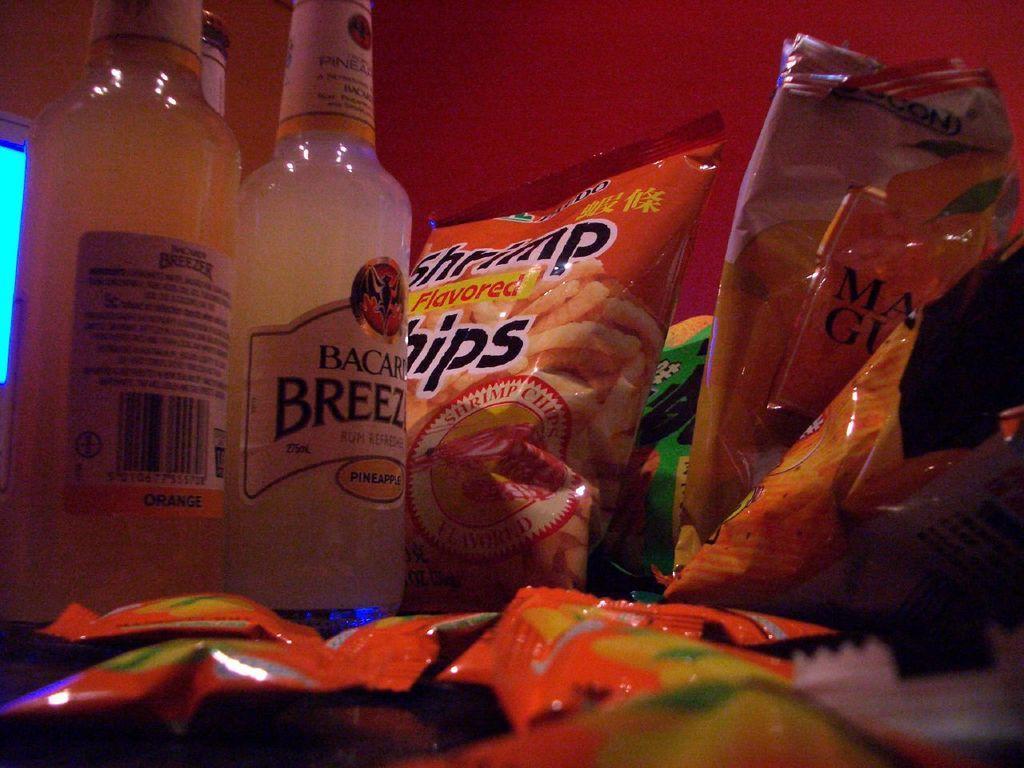Can you describe this image briefly? This picture shows two bottles and few snacks packets 